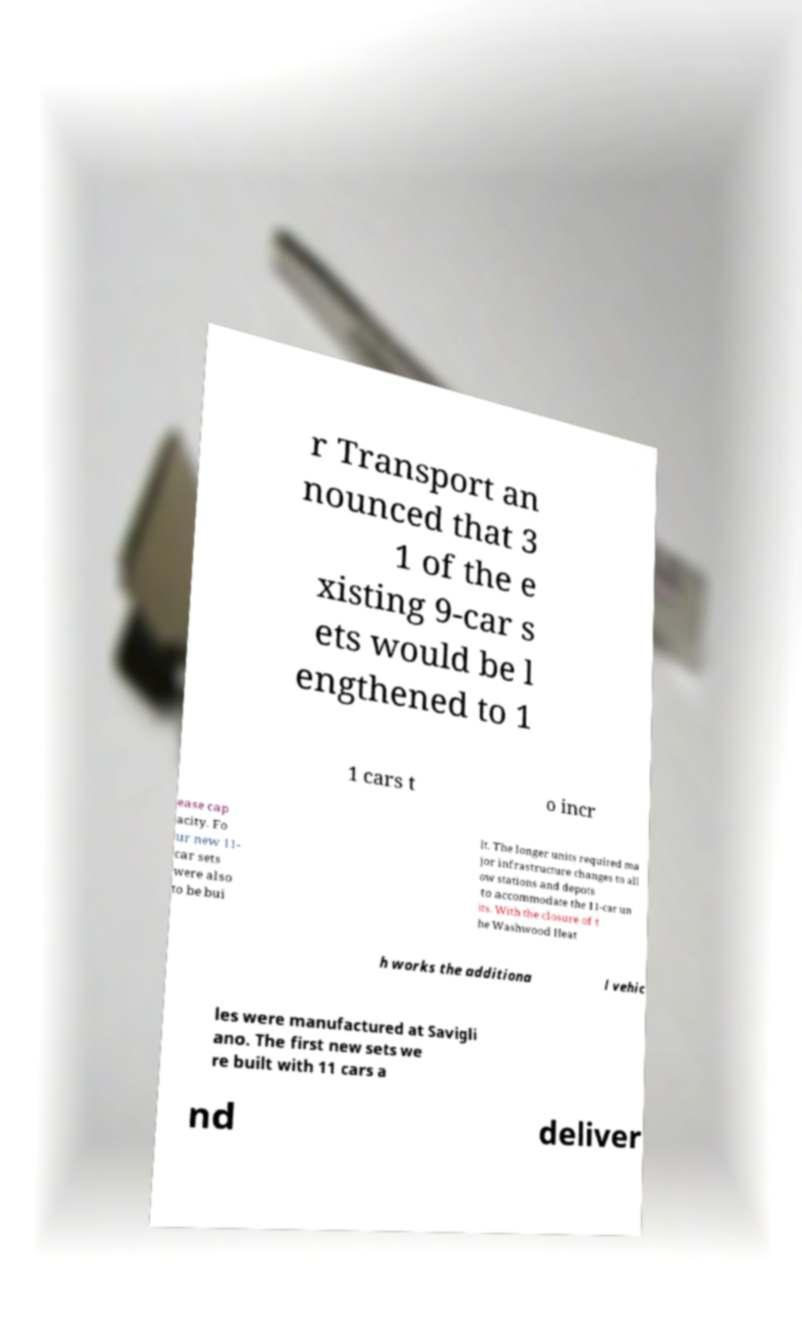Can you read and provide the text displayed in the image?This photo seems to have some interesting text. Can you extract and type it out for me? r Transport an nounced that 3 1 of the e xisting 9-car s ets would be l engthened to 1 1 cars t o incr ease cap acity. Fo ur new 11- car sets were also to be bui lt. The longer units required ma jor infrastructure changes to all ow stations and depots to accommodate the 11-car un its. With the closure of t he Washwood Heat h works the additiona l vehic les were manufactured at Savigli ano. The first new sets we re built with 11 cars a nd deliver 